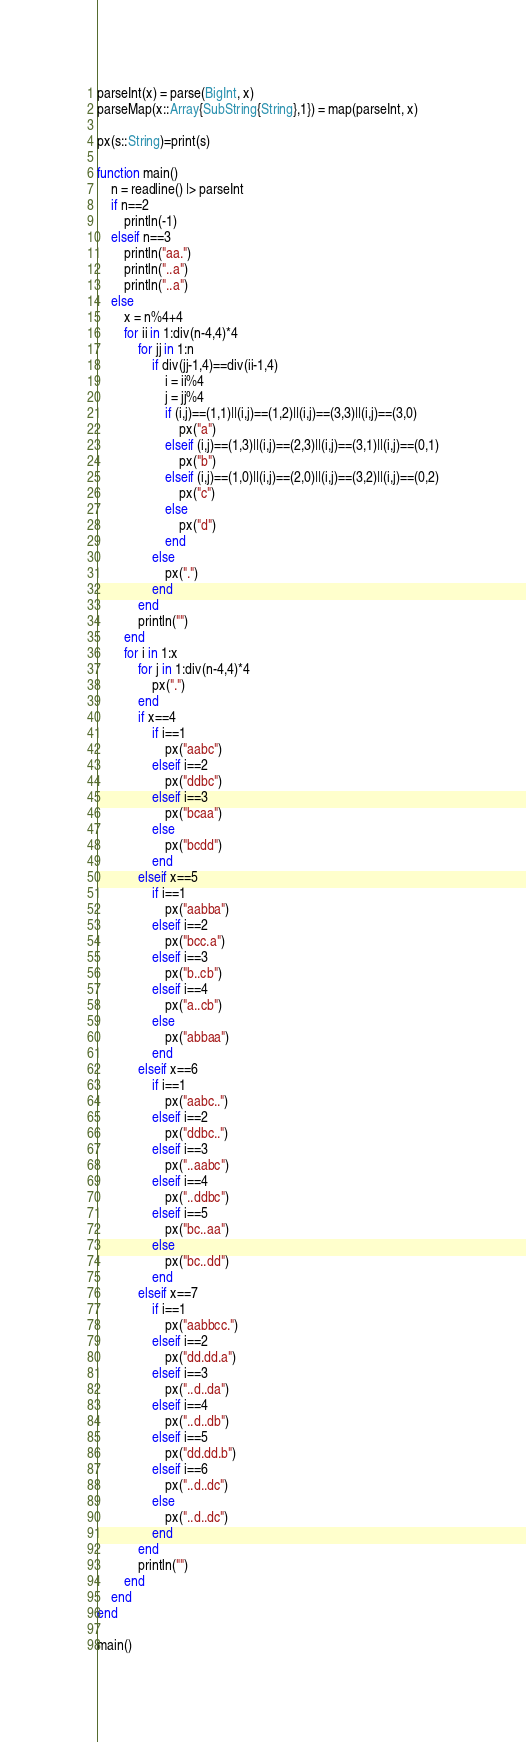<code> <loc_0><loc_0><loc_500><loc_500><_Julia_>parseInt(x) = parse(BigInt, x)
parseMap(x::Array{SubString{String},1}) = map(parseInt, x)

px(s::String)=print(s)

function main()
	n = readline() |> parseInt
	if n==2
		println(-1)
	elseif n==3
		println("aa.")
		println("..a")
		println("..a")
	else
		x = n%4+4
		for ii in 1:div(n-4,4)*4
			for jj in 1:n
				if div(jj-1,4)==div(ii-1,4)
					i = ii%4
					j = jj%4
					if (i,j)==(1,1)||(i,j)==(1,2)||(i,j)==(3,3)||(i,j)==(3,0)
						px("a")
					elseif (i,j)==(1,3)||(i,j)==(2,3)||(i,j)==(3,1)||(i,j)==(0,1)
						px("b")
					elseif (i,j)==(1,0)||(i,j)==(2,0)||(i,j)==(3,2)||(i,j)==(0,2)
						px("c")
					else
						px("d")
					end
				else
					px(".")
				end
			end
			println("")
		end
		for i in 1:x
			for j in 1:div(n-4,4)*4
				px(".")
			end
			if x==4
				if i==1
					px("aabc")
				elseif i==2
					px("ddbc")
				elseif i==3
					px("bcaa")
				else
					px("bcdd")
				end
			elseif x==5
				if i==1
					px("aabba")
				elseif i==2
					px("bcc.a")
				elseif i==3
					px("b..cb")
				elseif i==4
					px("a..cb")
				else
					px("abbaa")
				end
			elseif x==6
				if i==1
					px("aabc..")
				elseif i==2
					px("ddbc..")
				elseif i==3
					px("..aabc")
				elseif i==4
					px("..ddbc")
				elseif i==5
					px("bc..aa")
				else
					px("bc..dd")
				end
			elseif x==7
				if i==1
					px("aabbcc.")
				elseif i==2
					px("dd.dd.a")
				elseif i==3
					px("..d..da")
				elseif i==4
					px("..d..db")
				elseif i==5
					px("dd.dd.b")
				elseif i==6
					px("..d..dc")
				else
					px("..d..dc")
				end
			end
			println("")
		end
	end
end

main()</code> 